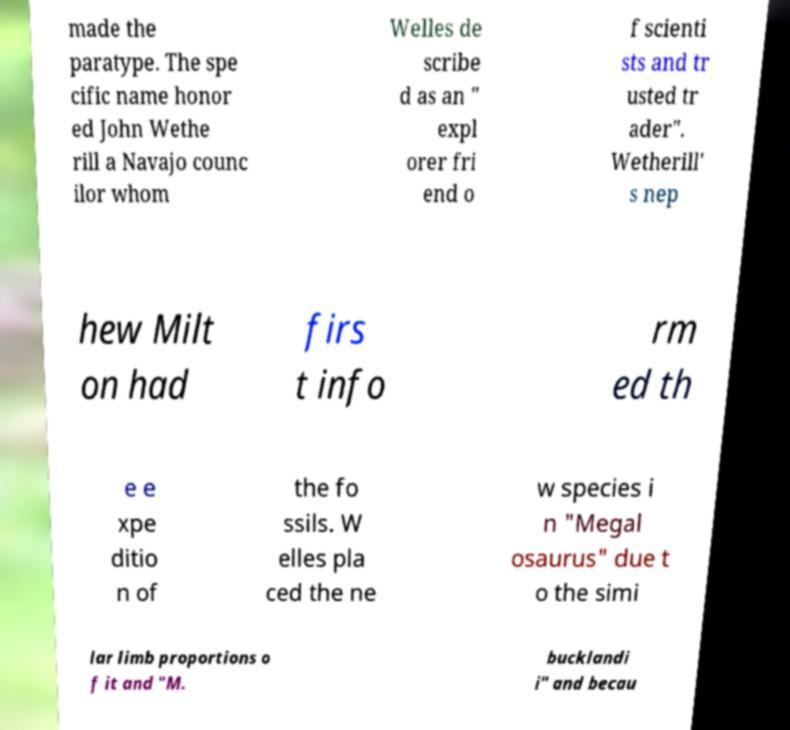Can you read and provide the text displayed in the image?This photo seems to have some interesting text. Can you extract and type it out for me? made the paratype. The spe cific name honor ed John Wethe rill a Navajo counc ilor whom Welles de scribe d as an " expl orer fri end o f scienti sts and tr usted tr ader". Wetherill' s nep hew Milt on had firs t info rm ed th e e xpe ditio n of the fo ssils. W elles pla ced the ne w species i n "Megal osaurus" due t o the simi lar limb proportions o f it and "M. bucklandi i" and becau 